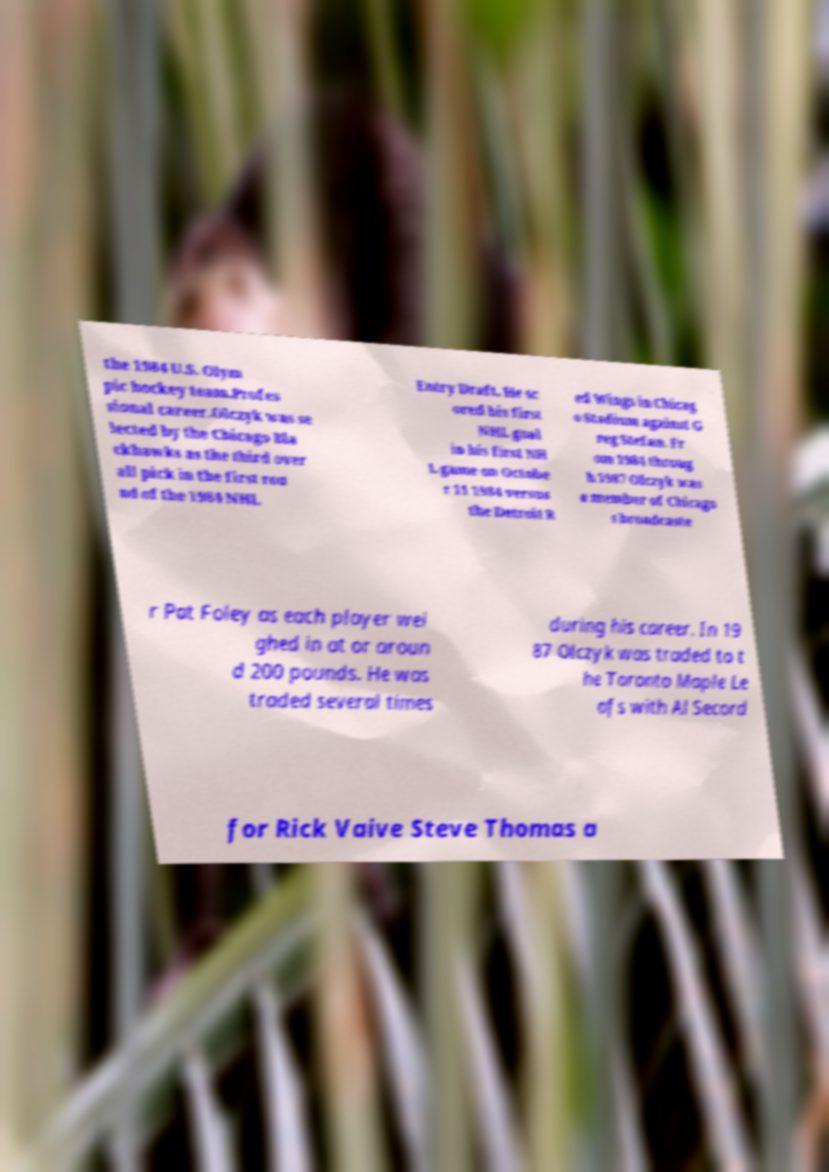Please identify and transcribe the text found in this image. the 1984 U.S. Olym pic hockey team.Profes sional career.Olczyk was se lected by the Chicago Bla ckhawks as the third over all pick in the first rou nd of the 1984 NHL Entry Draft. He sc ored his first NHL goal in his first NH L game on Octobe r 11 1984 versus the Detroit R ed Wings in Chicag o Stadium against G reg Stefan. Fr om 1984 throug h 1987 Olczyk was a member of Chicago s broadcaste r Pat Foley as each player wei ghed in at or aroun d 200 pounds. He was traded several times during his career. In 19 87 Olczyk was traded to t he Toronto Maple Le afs with Al Secord for Rick Vaive Steve Thomas a 